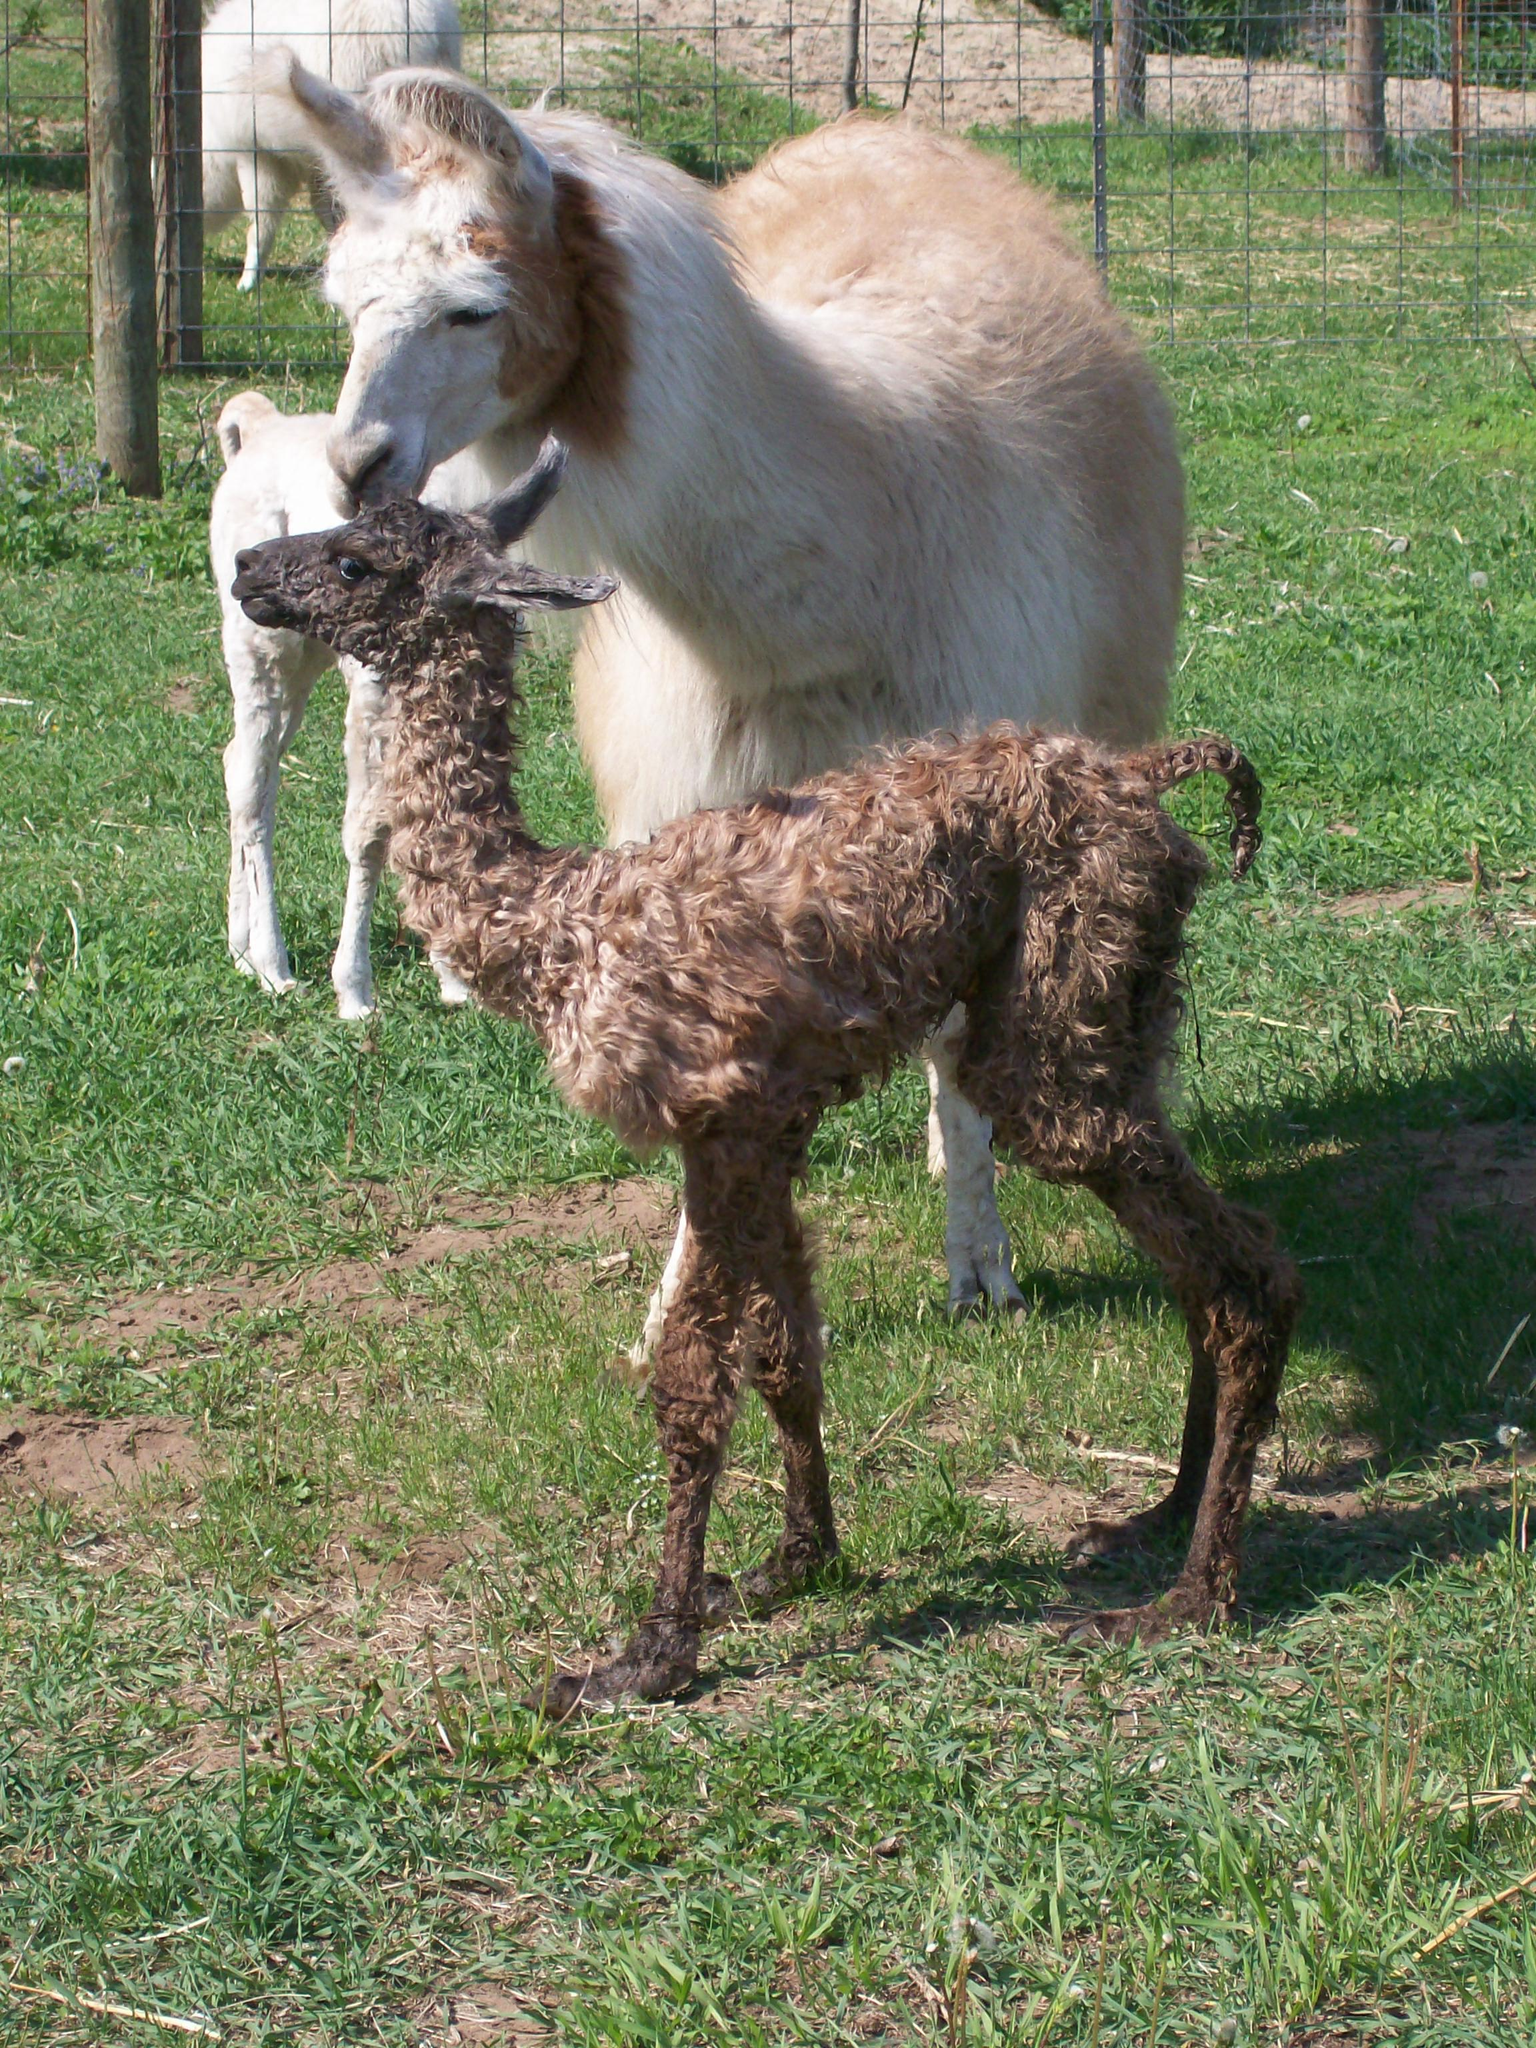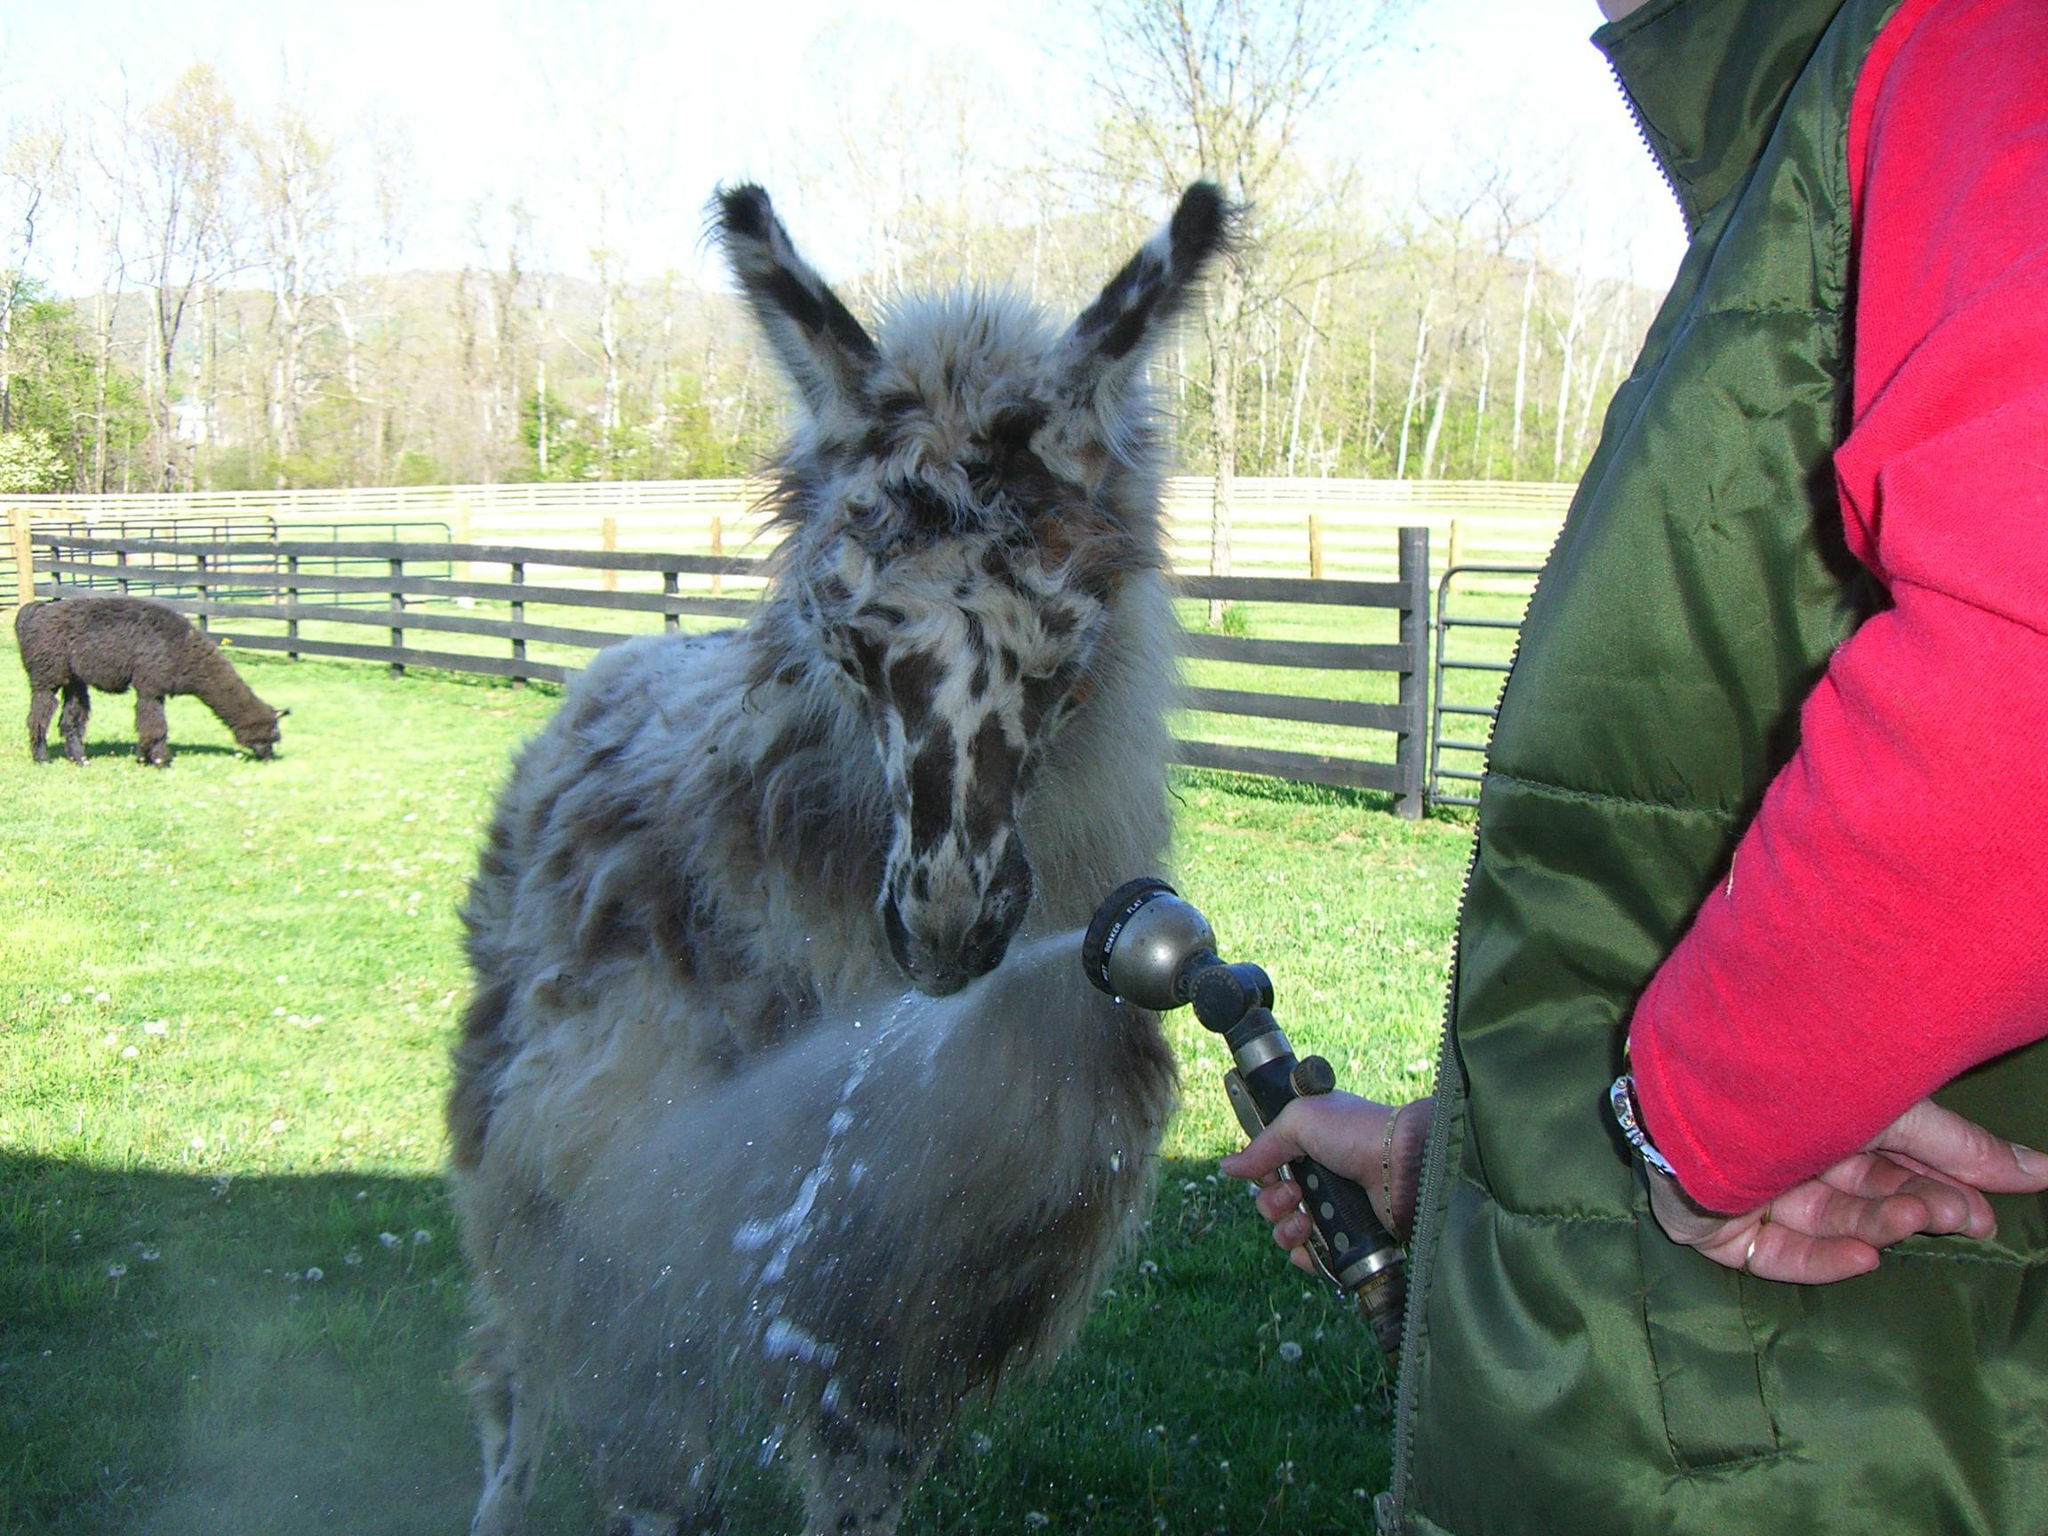The first image is the image on the left, the second image is the image on the right. Analyze the images presented: Is the assertion "A forward-turned llama is behind a blue swimming pool in the lefthand image." valid? Answer yes or no. No. The first image is the image on the left, the second image is the image on the right. Assess this claim about the two images: "The left image contains no more than one llama.". Correct or not? Answer yes or no. No. 